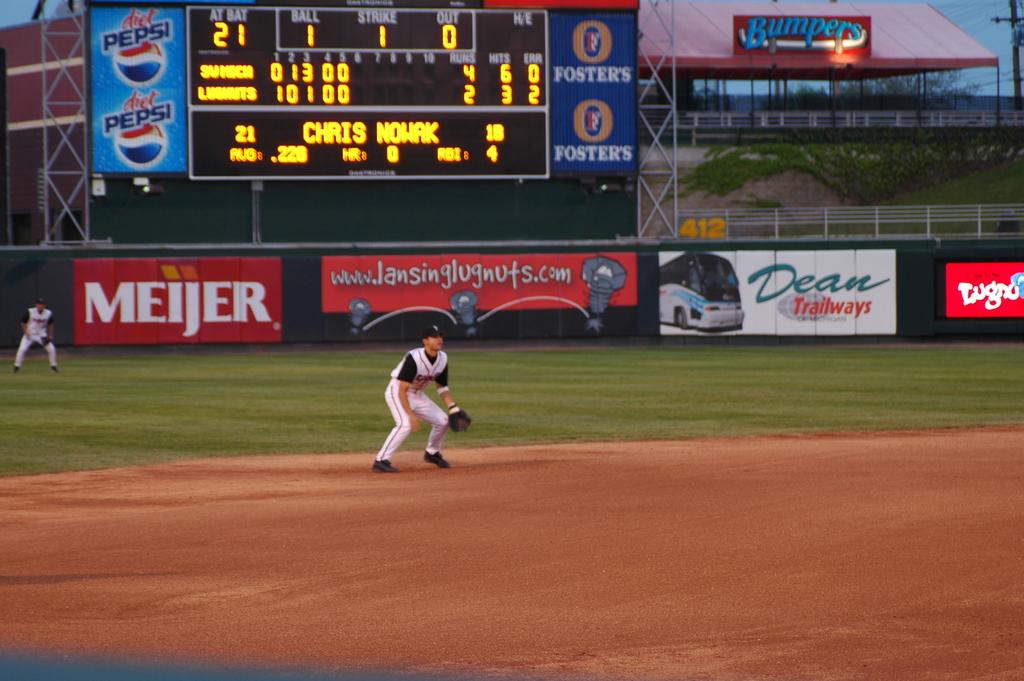Who is the sponsor on the red sign?
Ensure brevity in your answer.  Meijer. 